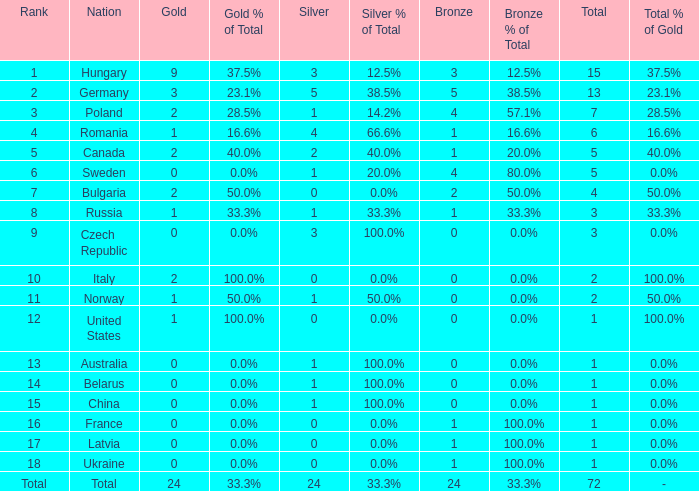What nation has 0 as the silver, 1 as the bronze, with 18 as the rank? Ukraine. 